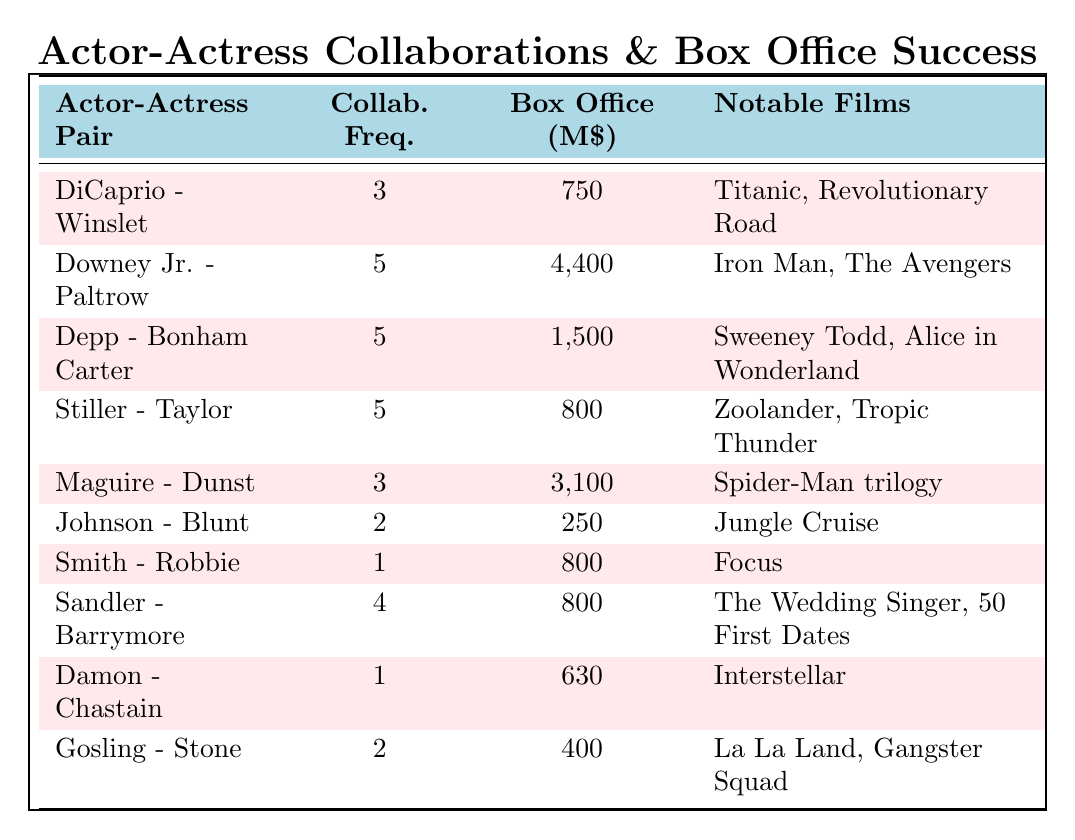What is the highest box office success among the actor-actress pairs listed? The table shows that Robert Downey Jr. and Gwyneth Paltrow's collaboration has the highest box office success at 4,400 million dollars.
Answer: 4,400 million dollars How many collaborations does Adam Sandler have with Drew Barrymore? The table indicates that Adam Sandler and Drew Barrymore collaborated 4 times.
Answer: 4 Which actor-actress pair has the lowest box office success? The table shows that Dwayne Johnson and Emily Blunt have the lowest box office success at 250 million dollars.
Answer: 250 million dollars What is the average collaboration frequency of the pairs listed? The sums of collaboration frequencies are 3 + 5 + 5 + 5 + 3 + 2 + 1 + 4 + 1 + 2 = 31, and there are 10 pairs, so the average is 31/10 = 3.1.
Answer: 3.1 Is there any actor-actress pair that collaborated only once? The table shows that both Will Smith and Margot Robbie, as well as Matt Damon and Jessica Chastain, collaborated only once.
Answer: Yes Which actor-actress pair has the most notable films listed? The highest number of notable films listed is by Robert Downey Jr. and Gwyneth Paltrow, with 4 notable films.
Answer: 4 films What is the total box office success of all collaborations with a frequency of 5? The pairs with 5 collaborations are Robert Downey Jr. & Gwyneth Paltrow (4,400 million) + Johnny Depp & Helena Bonham Carter (1,500 million) + Ben Stiller & Christine Taylor (800 million). Total = 4,400 + 1,500 + 800 = 6,700 million dollars.
Answer: 6,700 million dollars How many films are notable for the collaboration between Leonardo DiCaprio and Kate Winslet? The table indicates that Leonardo DiCaprio and Kate Winslet have 3 notable films listed.
Answer: 3 films Which actor-actress pair has a higher box office success, Tobey Maguire and Kirsten Dunst or Adam Sandler and Drew Barrymore? Tobey Maguire and Kirsten Dunst have a box office success of 3,100 million, which is higher than Adam Sandler and Drew Barrymore's 800 million.
Answer: Tobey Maguire and Kirsten Dunst What is the total number of collaborations for all actor-actress pairs listed? The total number of collaborations is 3 + 5 + 5 + 5 + 3 + 2 + 1 + 4 + 1 + 2 = 31.
Answer: 31 